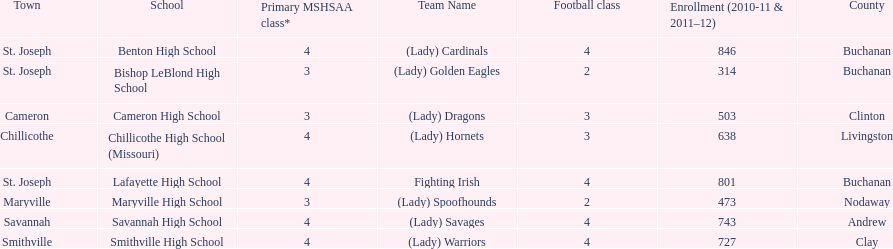What school has 3 football classes but only has 638 student enrollment? Chillicothe High School (Missouri). 